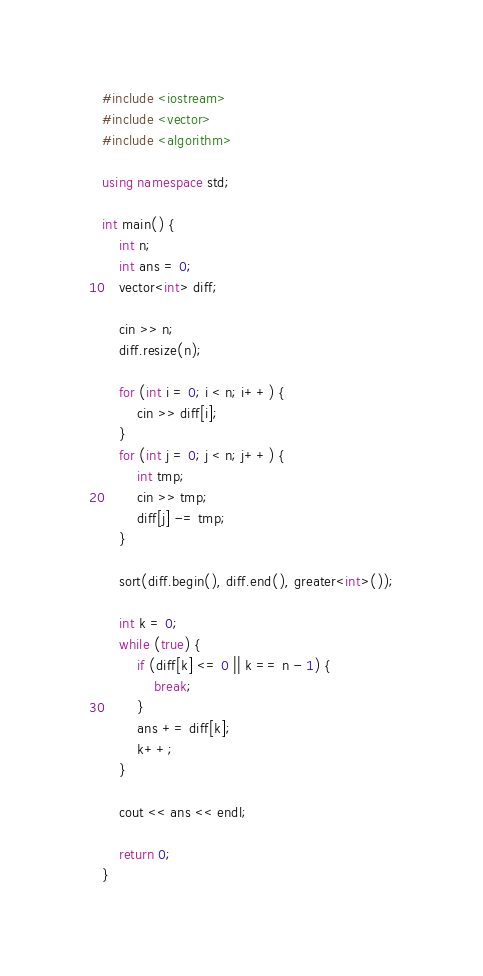Convert code to text. <code><loc_0><loc_0><loc_500><loc_500><_C++_>#include <iostream>
#include <vector>
#include <algorithm>

using namespace std;

int main() {
    int n;
    int ans = 0;
    vector<int> diff;

    cin >> n;
    diff.resize(n);

    for (int i = 0; i < n; i++) {
        cin >> diff[i];
    }
    for (int j = 0; j < n; j++) {
        int tmp;
        cin >> tmp;
        diff[j] -= tmp;
    }

    sort(diff.begin(), diff.end(), greater<int>());

    int k = 0;
    while (true) {
        if (diff[k] <= 0 || k == n - 1) {
            break;
        }
        ans += diff[k];
        k++;
    }

    cout << ans << endl;

    return 0;
}</code> 